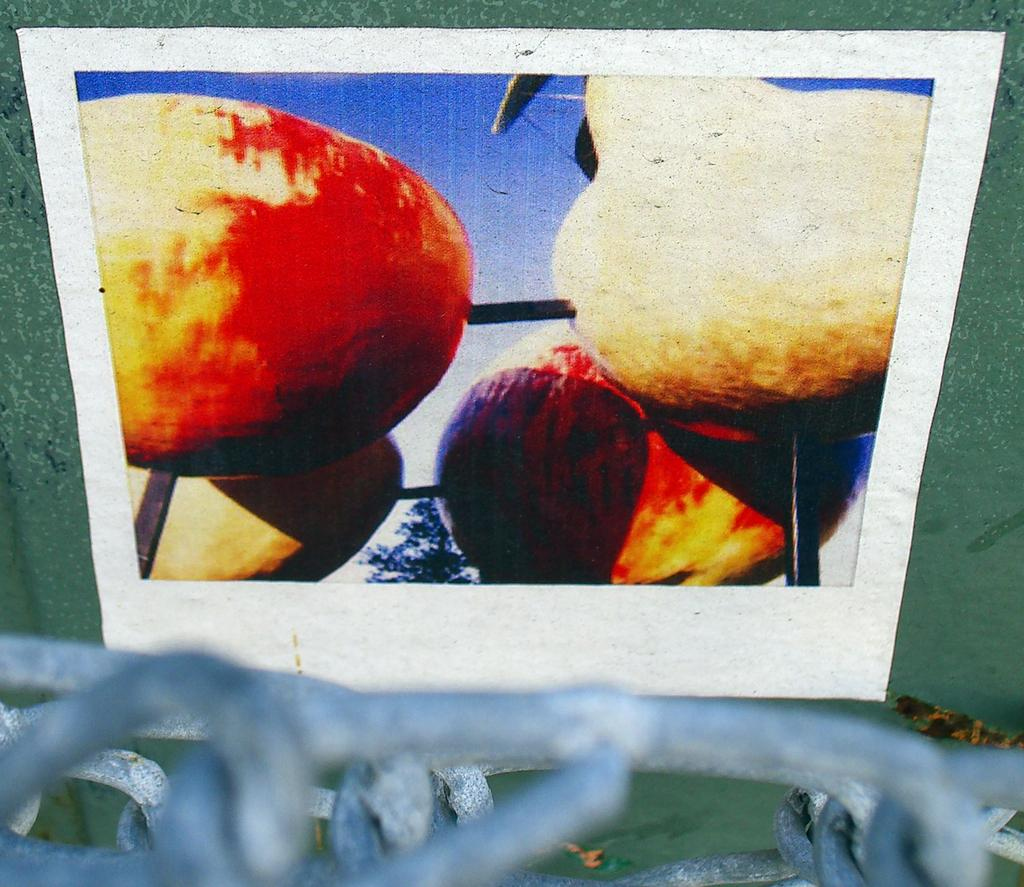What is on the wall in the image? There is a poster with images on the wall. Can you describe the objects at the bottom of the picture? Unfortunately, the provided facts do not give enough information to describe the objects at the bottom of the picture. How many eggs are being cracked by the shoe in the image? There is no shoe or eggs present in the image. 